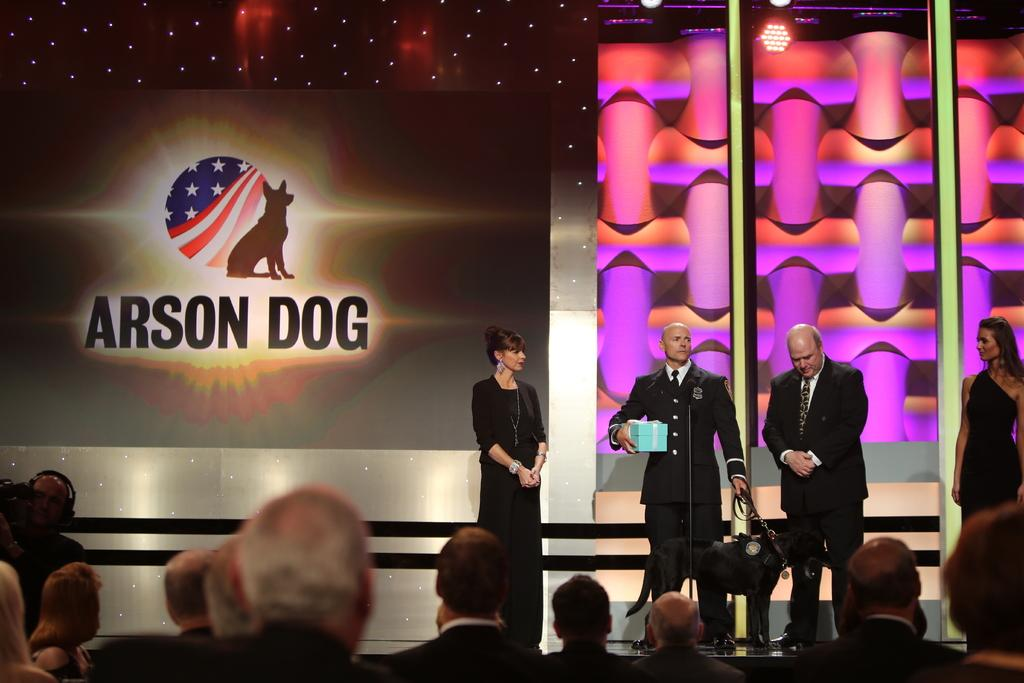<image>
Provide a brief description of the given image. Four people on a stage next to a screen that says Arson Dog 